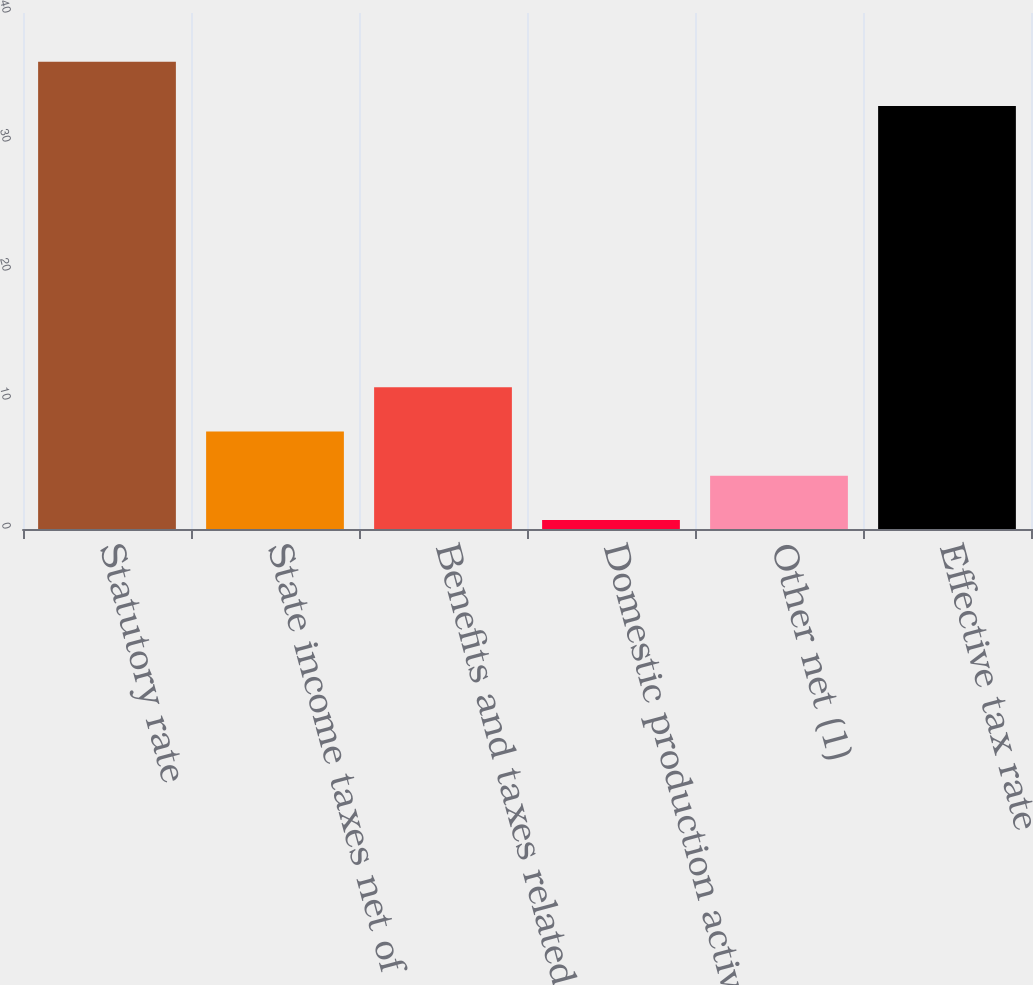Convert chart to OTSL. <chart><loc_0><loc_0><loc_500><loc_500><bar_chart><fcel>Statutory rate<fcel>State income taxes net of<fcel>Benefits and taxes related to<fcel>Domestic production activity<fcel>Other net (1)<fcel>Effective tax rate<nl><fcel>36.23<fcel>7.56<fcel>10.99<fcel>0.7<fcel>4.13<fcel>32.8<nl></chart> 